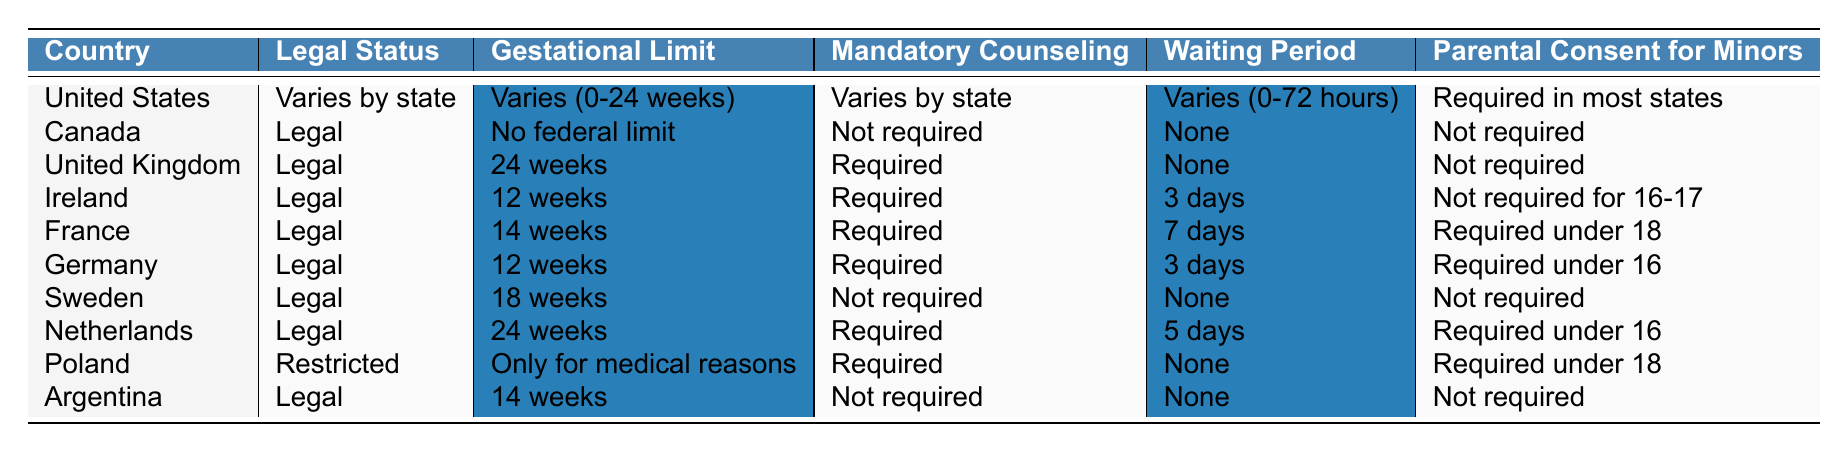What is the gestational limit for abortion in Germany? The table states that the gestational limit for abortion in Germany is 12 weeks.
Answer: 12 weeks Is parental consent required for minors in Canada? The table indicates that parental consent is not required in Canada for minors.
Answer: No Which country has the longest gestational limit for abortion? By checking the table, both the United Kingdom and the Netherlands have the longest gestational limit of 24 weeks.
Answer: United Kingdom and Netherlands How many countries require mandatory counseling before an abortion? The countries that require mandatory counseling are the United Kingdom, Ireland, France, Germany, and the Netherlands, totaling five countries.
Answer: 5 Is abortion legal in Poland? According to the table, Poland has a restricted legal status for abortion.
Answer: Yes, but restricted What is the average gestational limit for legal abortion among the listed countries? The legal gestational limits are: No federal limit (Canada), 24 weeks (United Kingdom, Netherlands), 12 weeks (Ireland, Germany), 14 weeks (France, Argentina), 18 weeks (Sweden). The sum is (∞ + 24 + 12 + 14 + 18) = 68, since “No federal limit” isn't a number, we take the average of the numeric values: (24 + 12 + 14 + 18) / 4 = 68 / 4 = 17.
Answer: 17 weeks How does the waiting period in the United States compare to other countries? In the table, the United States has a varying waiting period from 0 to 72 hours depending on the state, but other countries like Canada and Sweden have no waiting period. Therefore, the waiting period varies significantly in comparison.
Answer: Varies significantly Are minors required to obtain parental consent in Argentina? The table shows that parental consent is not required for minors in Argentina.
Answer: No Which two countries have the same gestational limit of 14 weeks? By checking the data, France and Argentina both have a gestational limit of 14 weeks.
Answer: France and Argentina What is the mandatory counseling requirement in Poland? The table indicates that Poland requires mandatory counseling before an abortion.
Answer: Required Is there a waiting period for abortion in Sweden? The table specifies that there is no waiting period for abortion in Sweden.
Answer: No 